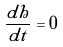Convert formula to latex. <formula><loc_0><loc_0><loc_500><loc_500>\frac { d h } { d t } = 0</formula> 